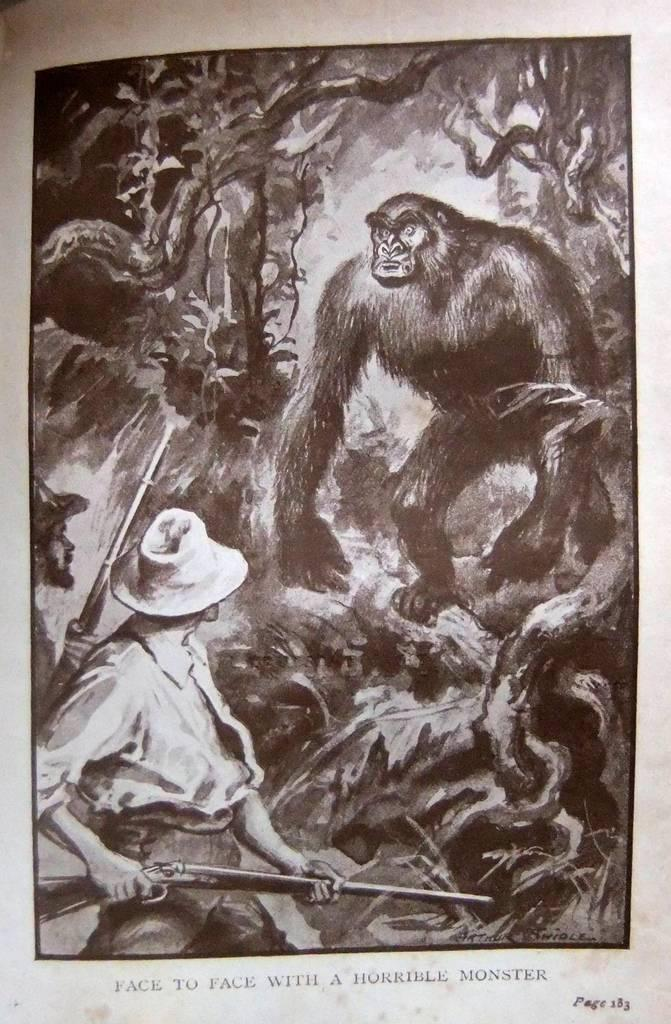What is present in the image that can be written on? There is a paper in the image that can be written on. What is the person holding in the image? The person is holding a gun in the image. What type of living creature is in the image? There is an animal in the image. What can be seen in the background of the image? There are trees in the background of the image. What information is visible at the bottom of the image? There is text visible at the bottom of the image. What type of tin can be seen in the image? There is no tin present in the image. What time of day is indicated by the hour in the image? There is no hour or time reference present in the image. 